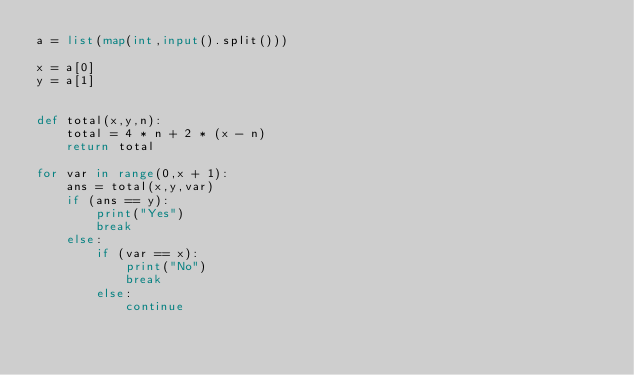Convert code to text. <code><loc_0><loc_0><loc_500><loc_500><_Python_>a = list(map(int,input().split()))

x = a[0]
y = a[1]


def total(x,y,n):
    total = 4 * n + 2 * (x - n)
    return total

for var in range(0,x + 1):
    ans = total(x,y,var)
    if (ans == y):
        print("Yes")
        break
    else:
        if (var == x):
            print("No")
            break
        else:
            continue
</code> 